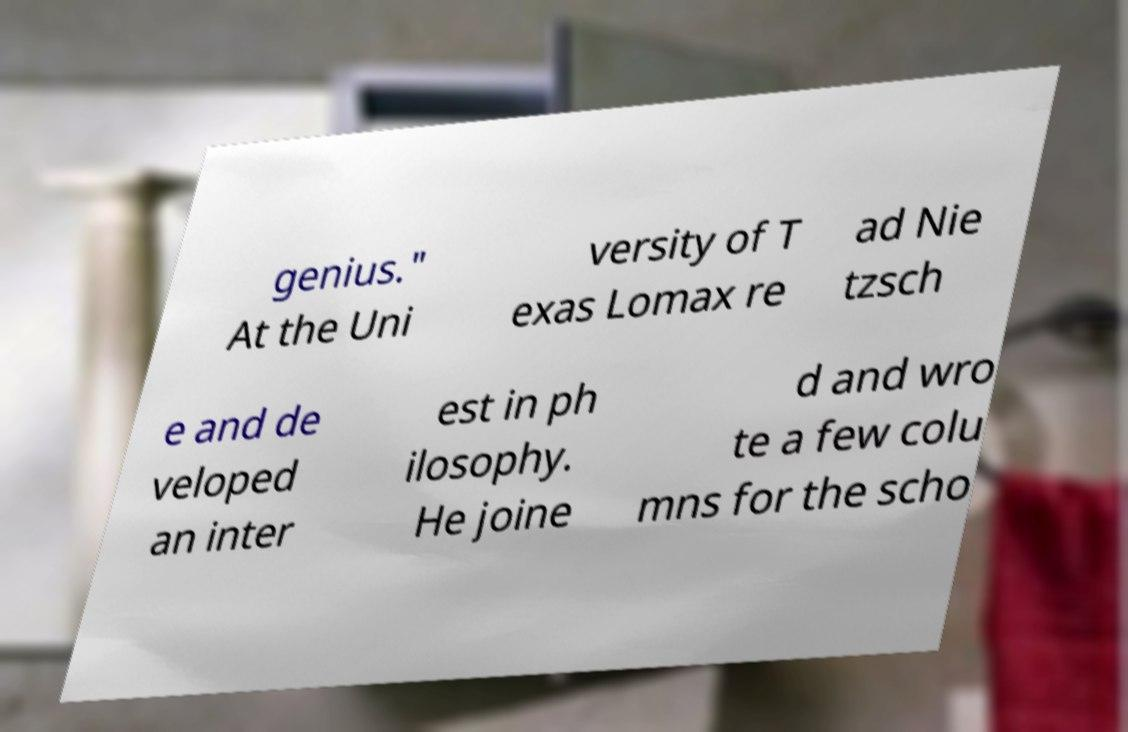Can you accurately transcribe the text from the provided image for me? genius." At the Uni versity of T exas Lomax re ad Nie tzsch e and de veloped an inter est in ph ilosophy. He joine d and wro te a few colu mns for the scho 